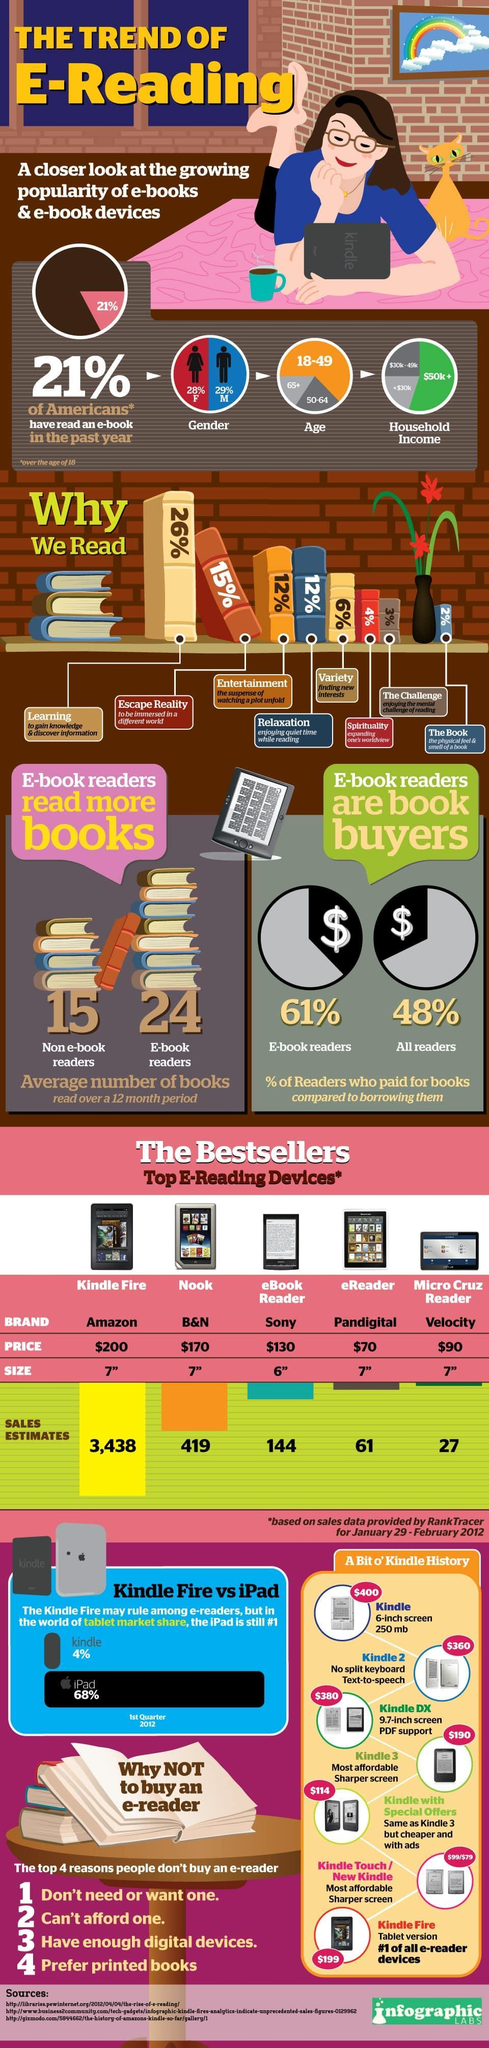what is the second most considerable reason not to but e-book devices?
Answer the question with a short phrase. can't afford one what is the second best seller among e-reading devices? Nook what majority of people think the purpose of reading is? learning which e-reading device among top 5 is the least expensive? eReader what percent of readers read for entertainment or relaxation? 24 which is the best seller among e-reading devices? Kindle fire which among top 5 e-reading devices is of 6 inch size? eBook reader what is the third most considerable reason not to but e-book devices? have enough digital devices 